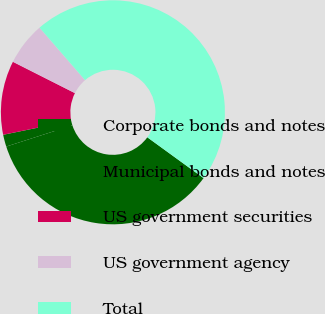Convert chart to OTSL. <chart><loc_0><loc_0><loc_500><loc_500><pie_chart><fcel>Corporate bonds and notes<fcel>Municipal bonds and notes<fcel>US government securities<fcel>US government agency<fcel>Total<nl><fcel>35.06%<fcel>1.73%<fcel>10.66%<fcel>6.19%<fcel>46.36%<nl></chart> 